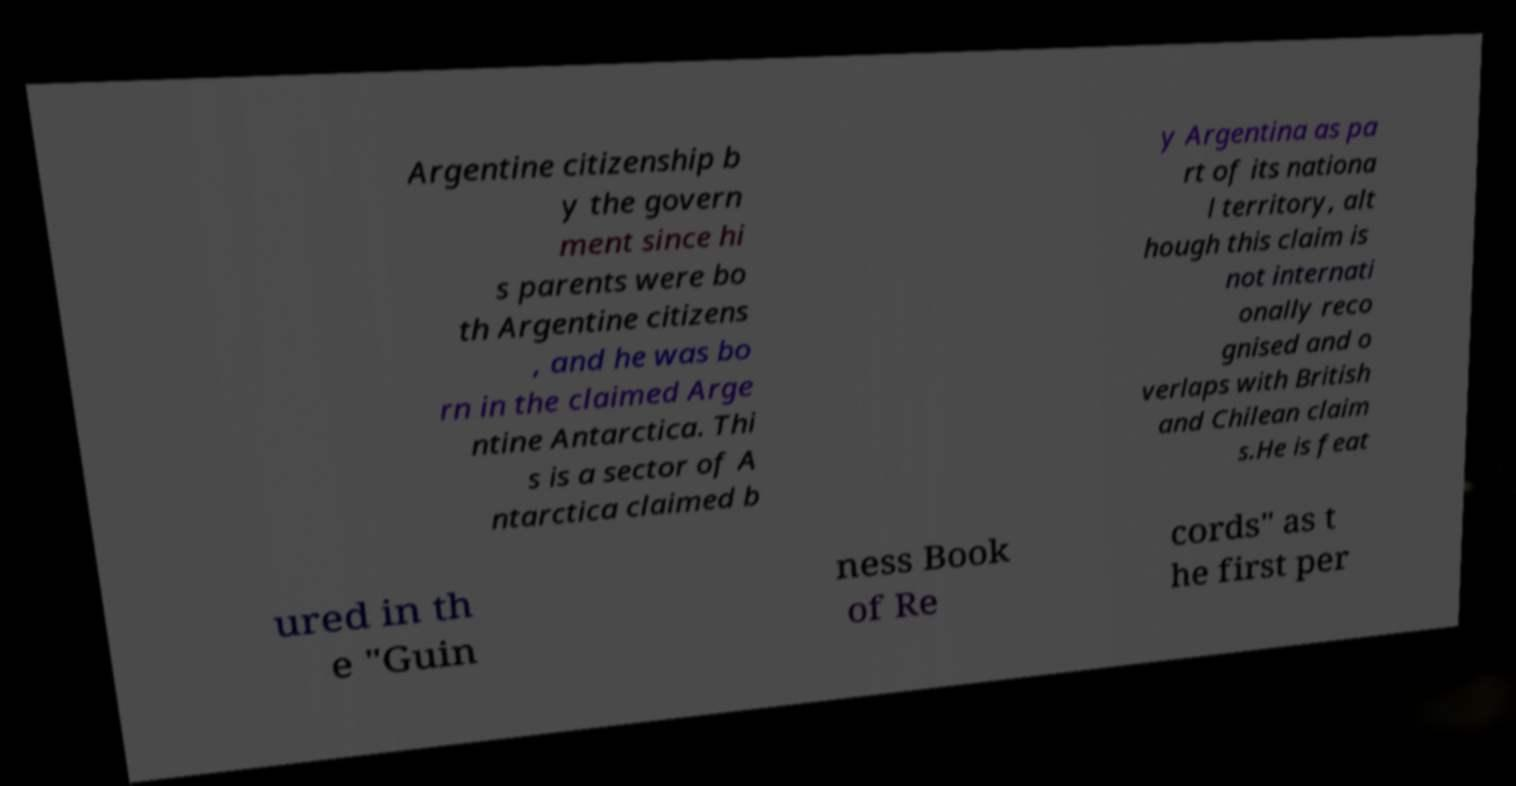Please read and relay the text visible in this image. What does it say? Argentine citizenship b y the govern ment since hi s parents were bo th Argentine citizens , and he was bo rn in the claimed Arge ntine Antarctica. Thi s is a sector of A ntarctica claimed b y Argentina as pa rt of its nationa l territory, alt hough this claim is not internati onally reco gnised and o verlaps with British and Chilean claim s.He is feat ured in th e "Guin ness Book of Re cords" as t he first per 